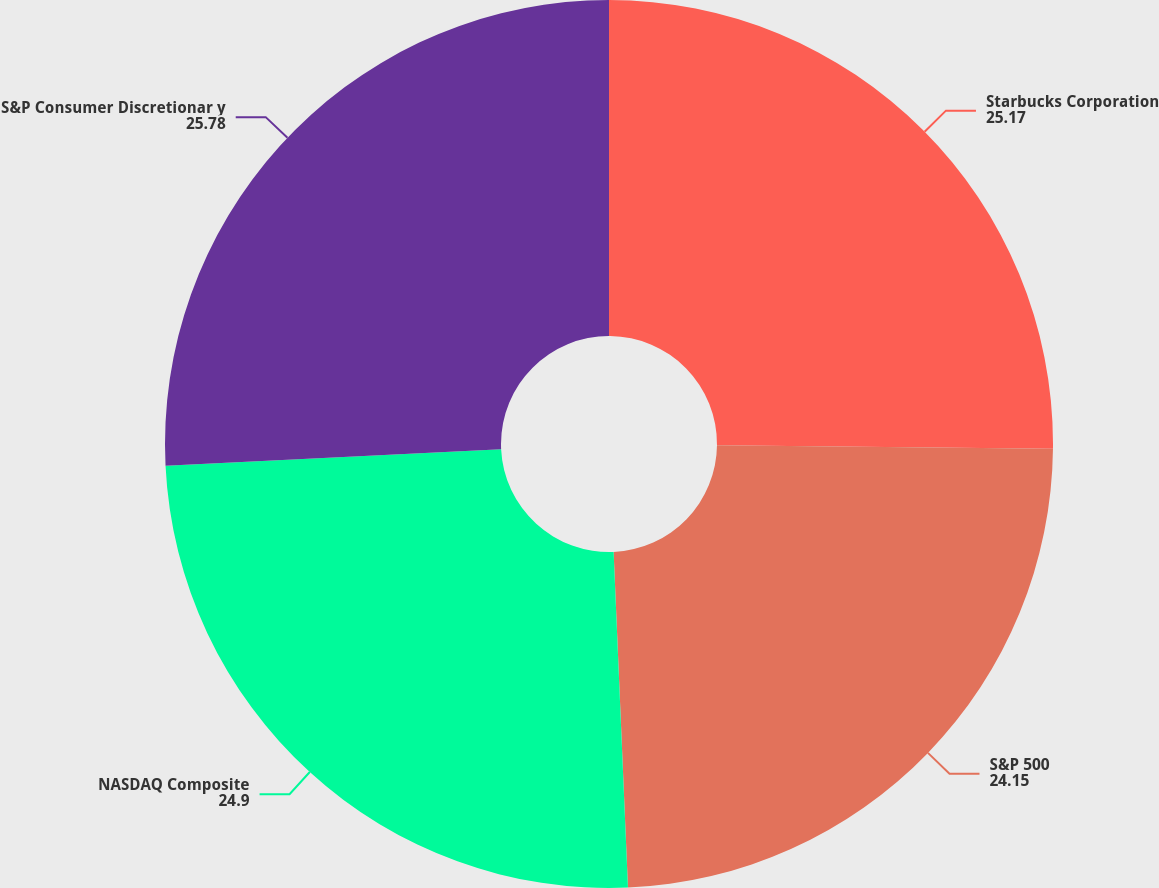<chart> <loc_0><loc_0><loc_500><loc_500><pie_chart><fcel>Starbucks Corporation<fcel>S&P 500<fcel>NASDAQ Composite<fcel>S&P Consumer Discretionar y<nl><fcel>25.17%<fcel>24.15%<fcel>24.9%<fcel>25.78%<nl></chart> 